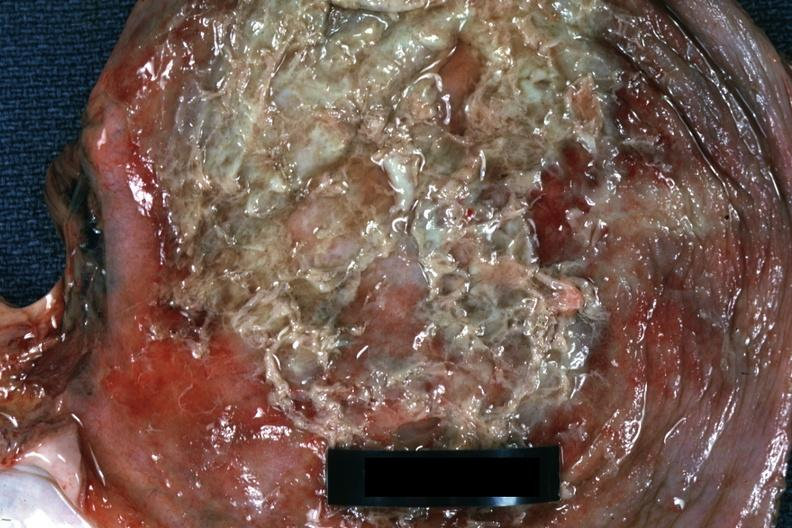what is present?
Answer the question using a single word or phrase. Muscle 